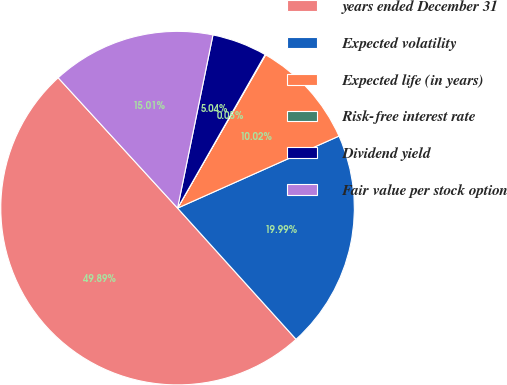Convert chart. <chart><loc_0><loc_0><loc_500><loc_500><pie_chart><fcel>years ended December 31<fcel>Expected volatility<fcel>Expected life (in years)<fcel>Risk-free interest rate<fcel>Dividend yield<fcel>Fair value per stock option<nl><fcel>49.89%<fcel>19.99%<fcel>10.02%<fcel>0.05%<fcel>5.04%<fcel>15.01%<nl></chart> 